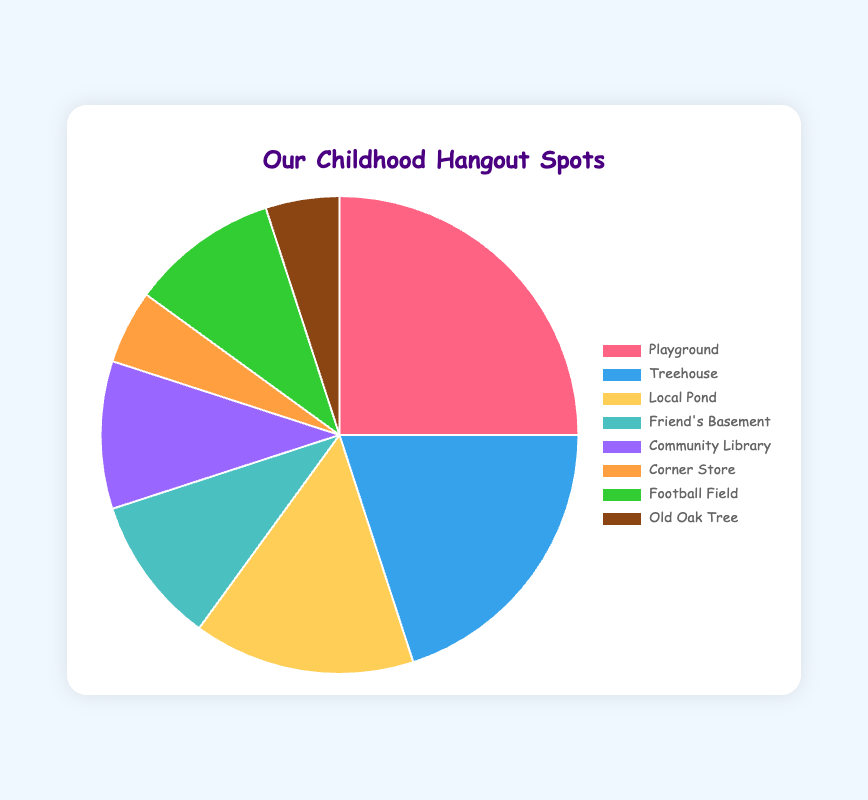Which spot had the largest share of time spent? The largest segment in the pie chart represents the Playground with 25% of the share, which makes it the largest among the listed spots.
Answer: Playground Which two spots had the smallest shares of time spent, and what were their percentages? The smallest segments in the pie chart represent the Corner Store and Old Oak Tree, each with 5% of the share.
Answer: Corner Store and Old Oak Tree with 5% What's the total percentage of time spent in the Playground and Treehouse combined? The percentages for Playground and Treehouse are 25% and 20%, respectively. Adding them gives 25 + 20 = 45%.
Answer: 45% Is the time spent at the Local Pond greater than that at Friend's Basement, and by how much? The Local Pond has 15% of time spent, while Friend's Basement has 10%. The difference is 15 - 10 = 5%.
Answer: Yes, by 5% How does the percentage of time spent at the Football Field compare to the percentage of time at the Community Library? Both the Football Field and the Community Library have 10% of the time spent.
Answer: Equal What is the total percentage of time spent in the Playground, Local Pond, and Friend's Basement? Summing the percentages gives 25% (Playground) + 15% (Local Pond) + 10% (Friend's Basement) = 50%.
Answer: 50% What are the total percentages of time spent in spots with more than 10%? Spots with more than 10% are Playground (25%) and Treehouse (20%). So, 25 + 20 = 45%.
Answer: 45% Which spot is represented by the green segment of the pie chart? The green segment of the pie chart corresponds to the Football Field with 10% time spent.
Answer: Football Field 